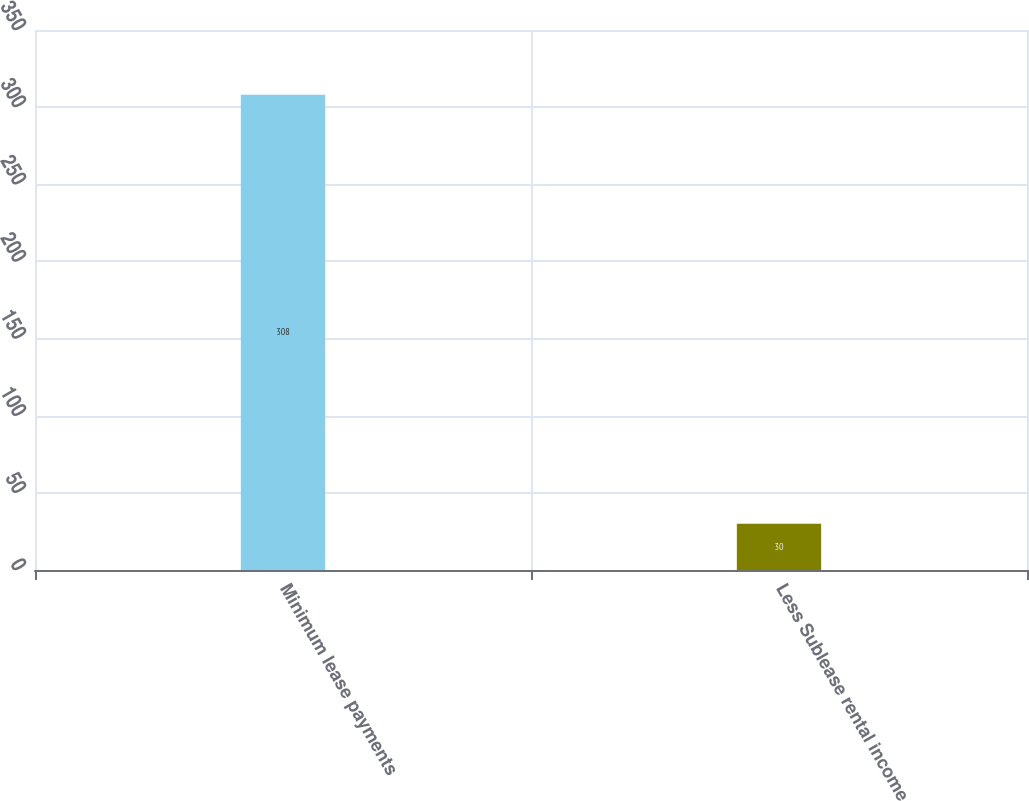Convert chart to OTSL. <chart><loc_0><loc_0><loc_500><loc_500><bar_chart><fcel>Minimum lease payments<fcel>Less Sublease rental income<nl><fcel>308<fcel>30<nl></chart> 